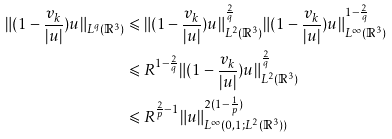<formula> <loc_0><loc_0><loc_500><loc_500>\| ( 1 - \frac { v _ { k } } { | u | } ) u \| _ { L ^ { q } ( \mathbb { R } ^ { 3 } ) } & \leqslant \| ( 1 - \frac { v _ { k } } { | u | } ) u \| _ { L ^ { 2 } ( \mathbb { R } ^ { 3 } ) } ^ { \frac { 2 } { q } } \| ( 1 - \frac { v _ { k } } { | u | } ) u \| _ { L ^ { \infty } ( \mathbb { R } ^ { 3 } ) } ^ { 1 - \frac { 2 } { q } } \\ & \leqslant R ^ { 1 - \frac { 2 } { q } } \| ( 1 - \frac { v _ { k } } { | u | } ) u \| _ { L ^ { 2 } ( \mathbb { R } ^ { 3 } ) } ^ { \frac { 2 } { q } } \\ & \leqslant R ^ { \frac { 2 } { p } - 1 } \| u \| _ { L ^ { \infty } ( 0 , 1 ; L ^ { 2 } ( \mathbb { R } ^ { 3 } ) ) } ^ { 2 ( 1 - \frac { 1 } { p } ) }</formula> 